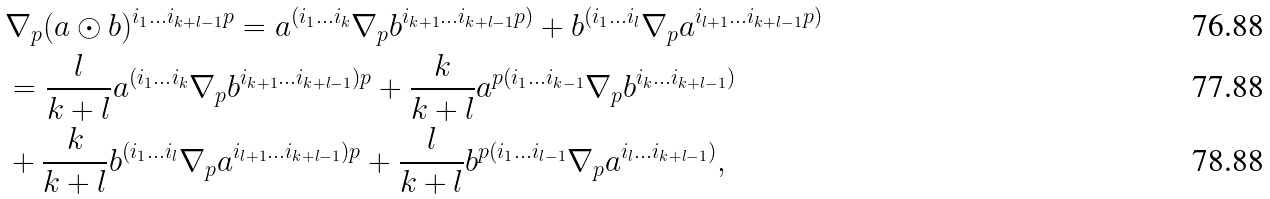Convert formula to latex. <formula><loc_0><loc_0><loc_500><loc_500>& \nabla _ { p } ( a \odot b ) ^ { i _ { 1 } \dots i _ { k + l - 1 } p } = a ^ { ( i _ { 1 } \dots i _ { k } } \nabla _ { p } b ^ { i _ { k + 1 } \dots i _ { k + l - 1 } p ) } + b ^ { ( i _ { 1 } \dots i _ { l } } \nabla _ { p } a ^ { i _ { l + 1 } \dots i _ { k + l - 1 } p ) } \\ & = \frac { l } { k + l } a ^ { ( i _ { 1 } \dots i _ { k } } \nabla _ { p } b ^ { i _ { k + 1 } \dots i _ { k + l - 1 } ) p } + \frac { k } { k + l } a ^ { p ( i _ { 1 } \dots i _ { k - 1 } } \nabla _ { p } b ^ { i _ { k } \dots i _ { k + l - 1 } ) } \\ & + \frac { k } { k + l } b ^ { ( i _ { 1 } \dots i _ { l } } \nabla _ { p } a ^ { i _ { l + 1 } \dots i _ { k + l - 1 } ) p } + \frac { l } { k + l } b ^ { p ( i _ { 1 } \dots i _ { l - 1 } } \nabla _ { p } a ^ { i _ { l } \dots i _ { k + l - 1 } ) } ,</formula> 